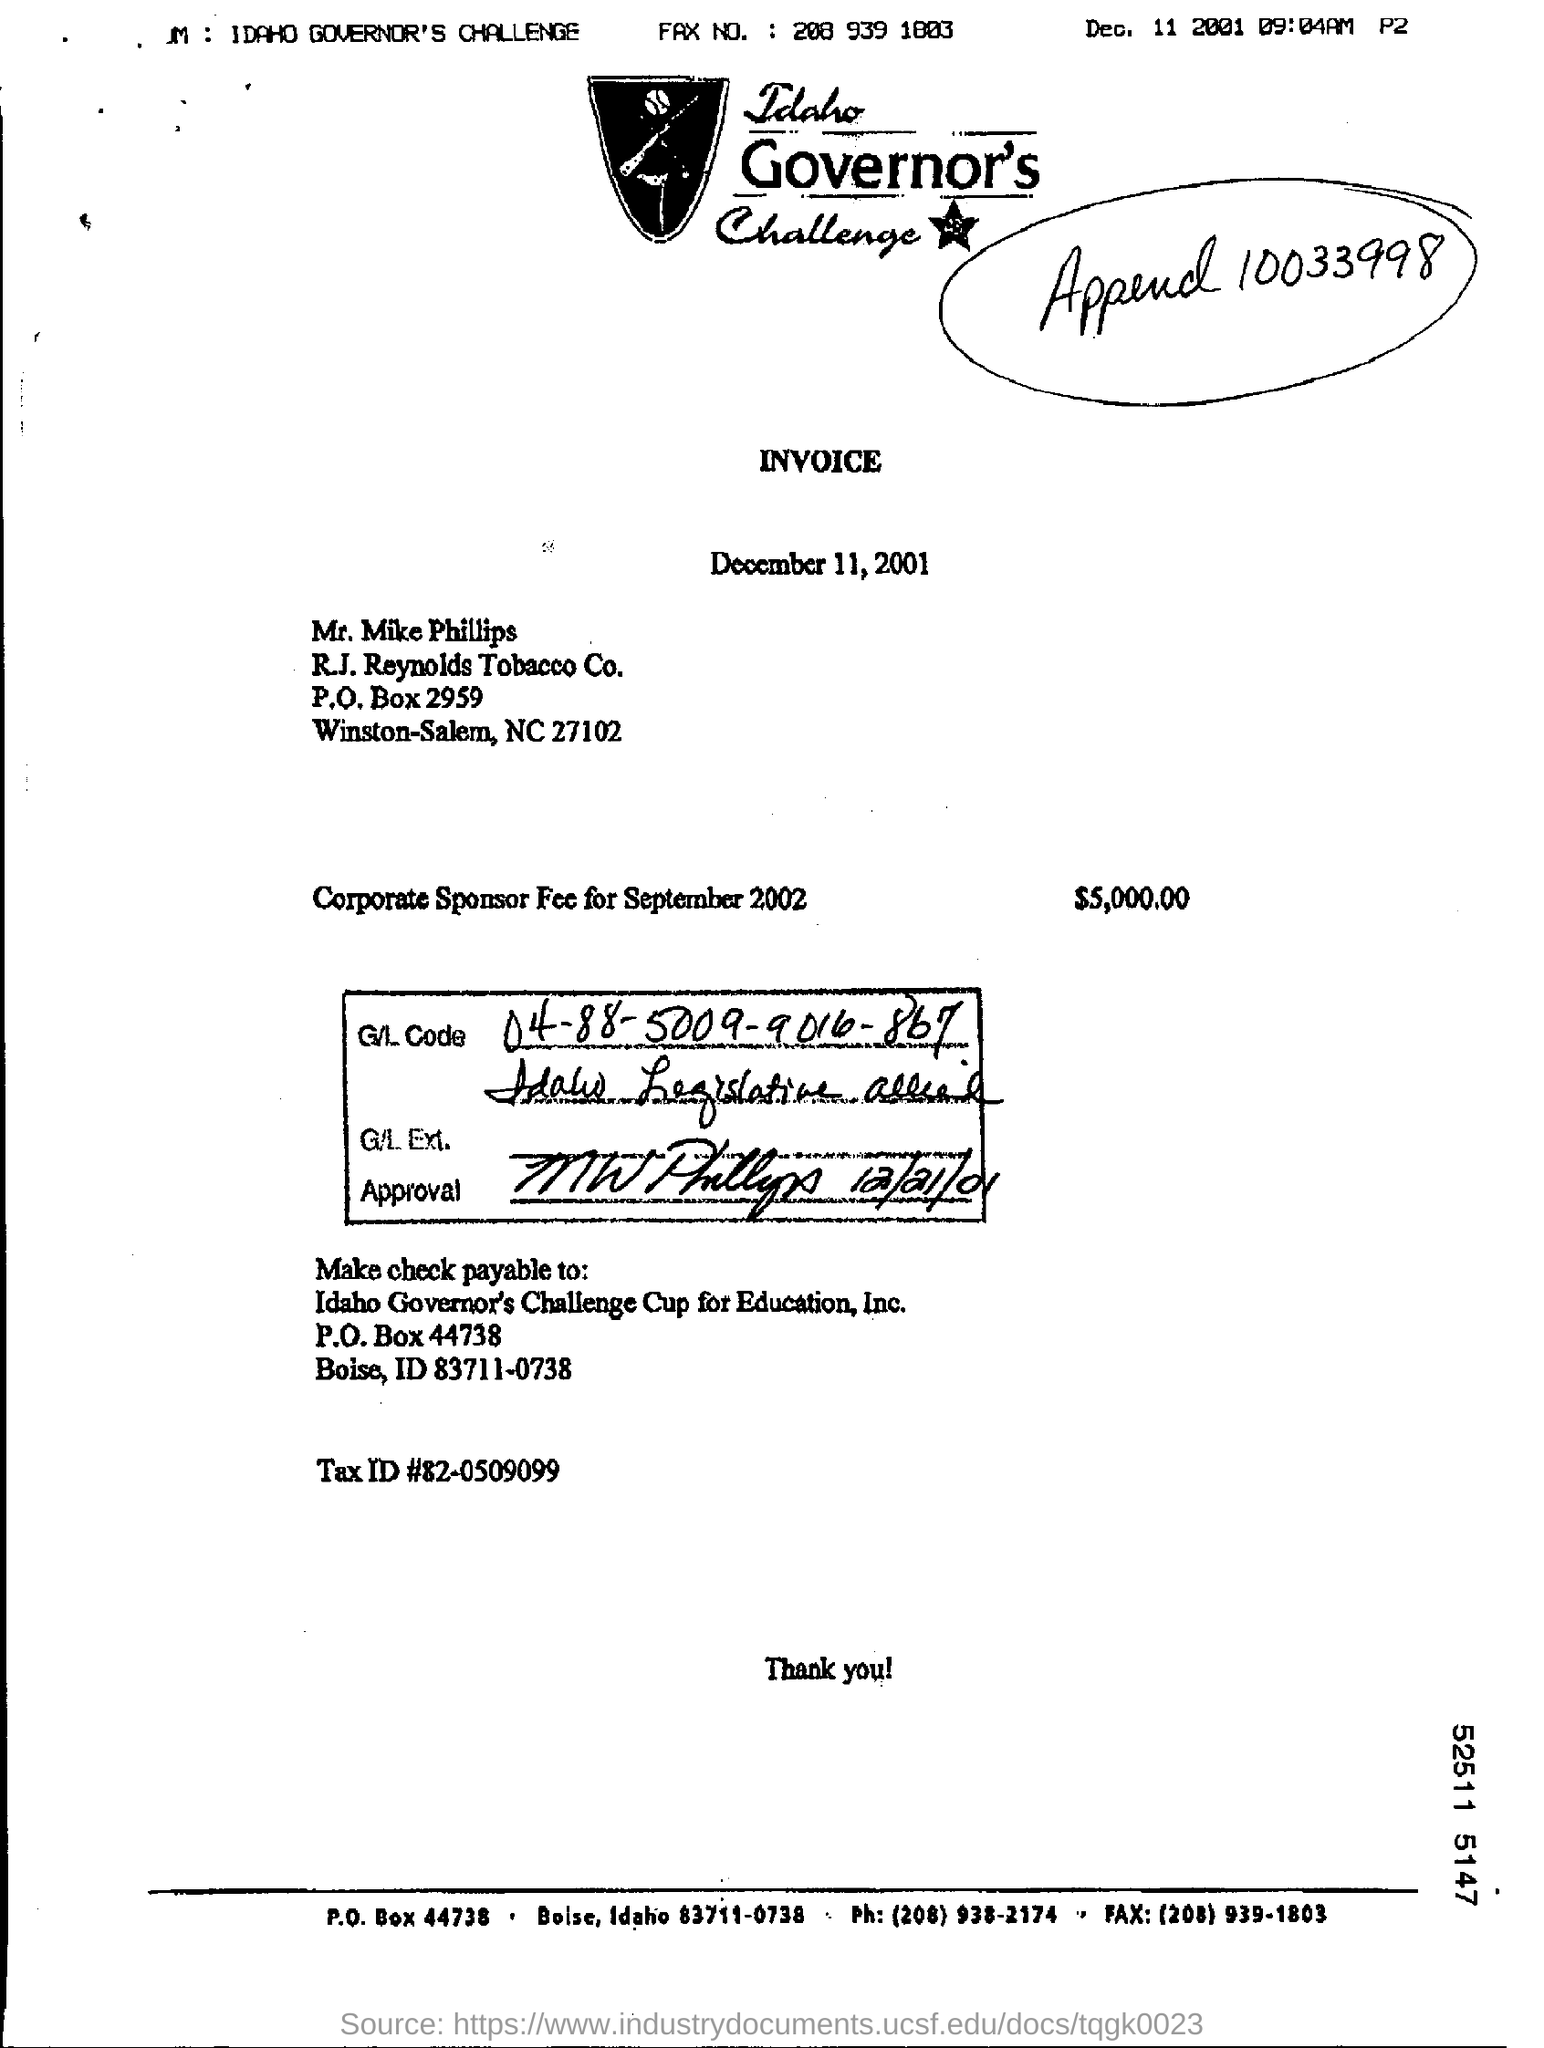Specify some key components in this picture. The corporate sponsor fee for September 2002 was $5,000.00 